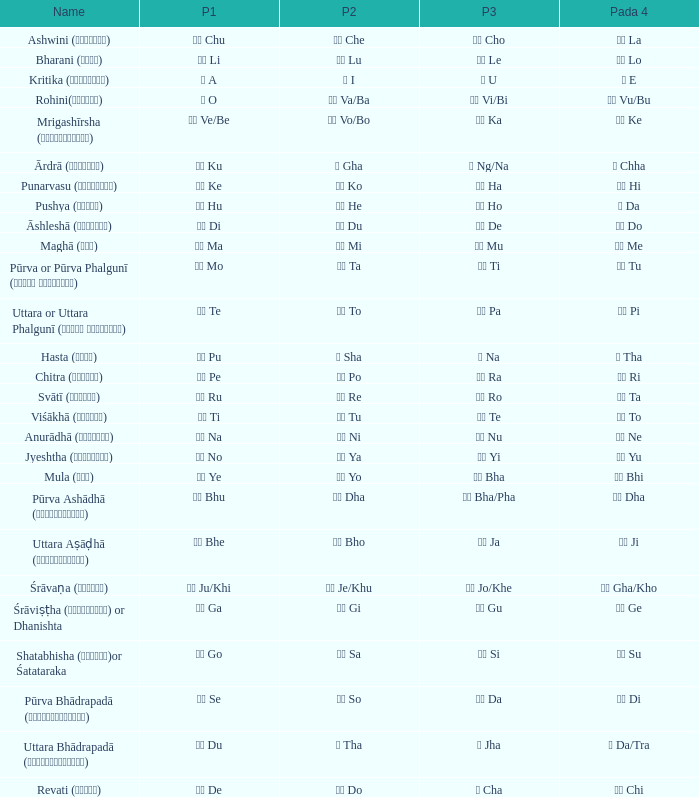Which pada 3 has a pada 2 of चे che? चो Cho. 